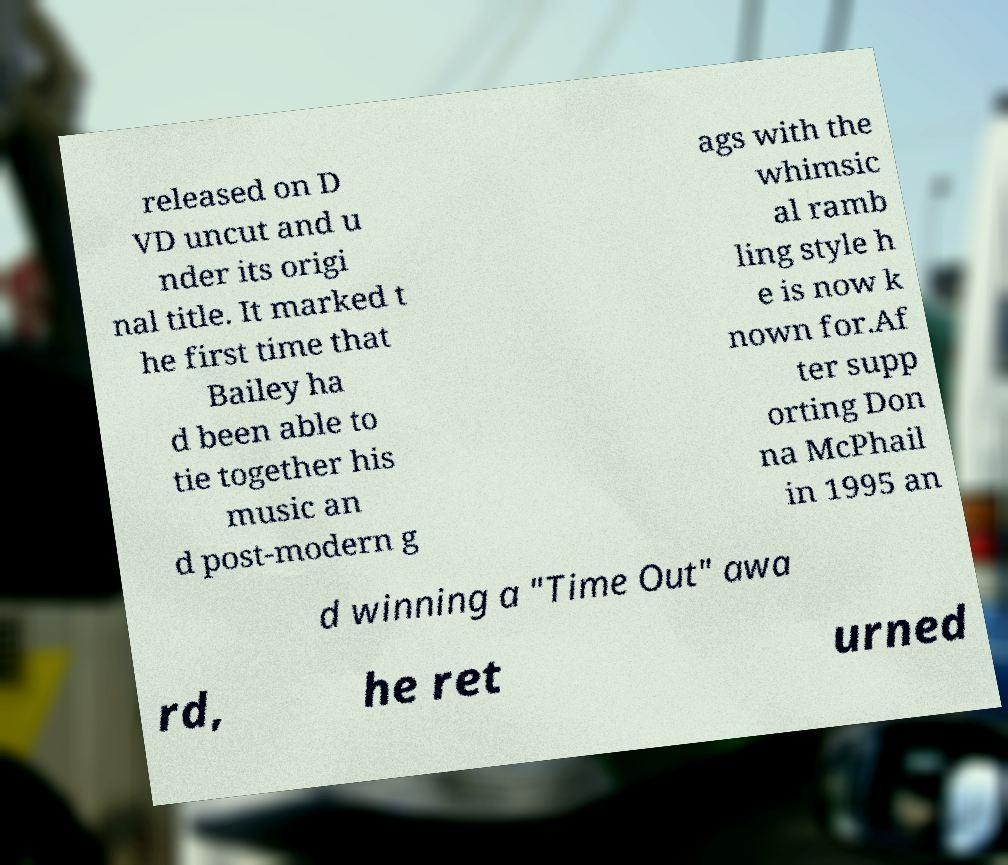Can you accurately transcribe the text from the provided image for me? released on D VD uncut and u nder its origi nal title. It marked t he first time that Bailey ha d been able to tie together his music an d post-modern g ags with the whimsic al ramb ling style h e is now k nown for.Af ter supp orting Don na McPhail in 1995 an d winning a "Time Out" awa rd, he ret urned 